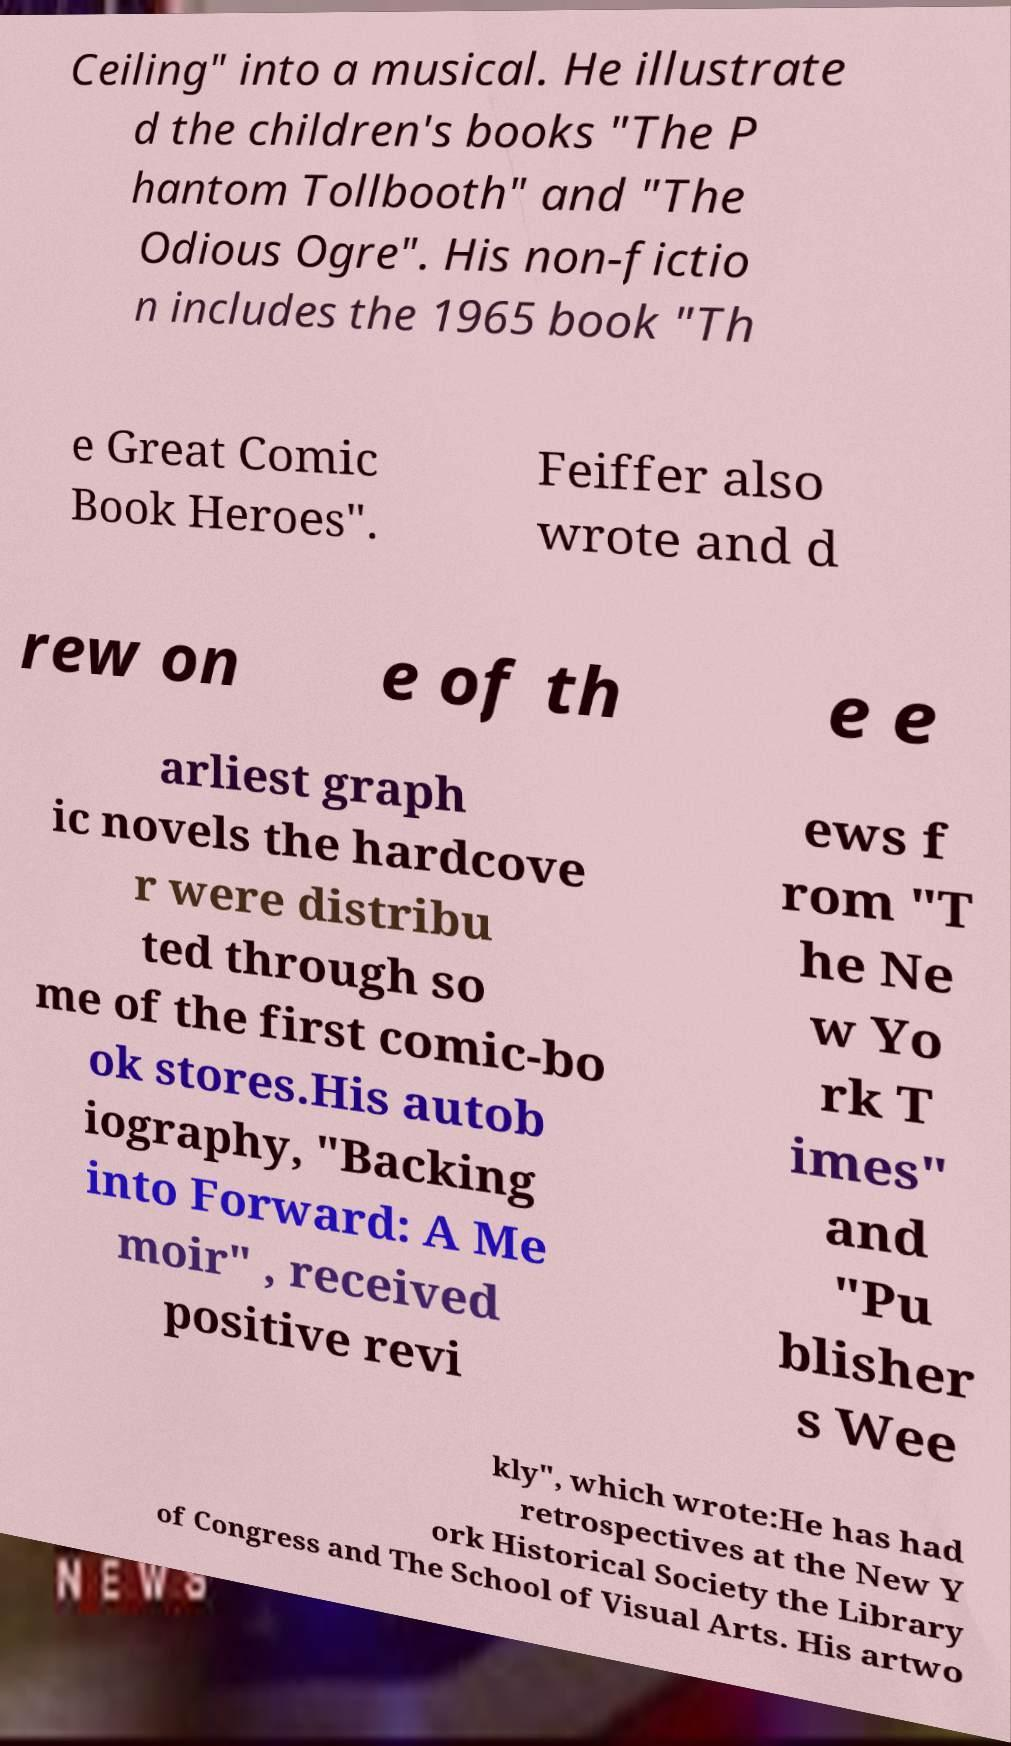What messages or text are displayed in this image? I need them in a readable, typed format. Ceiling" into a musical. He illustrate d the children's books "The P hantom Tollbooth" and "The Odious Ogre". His non-fictio n includes the 1965 book "Th e Great Comic Book Heroes". Feiffer also wrote and d rew on e of th e e arliest graph ic novels the hardcove r were distribu ted through so me of the first comic-bo ok stores.His autob iography, "Backing into Forward: A Me moir" , received positive revi ews f rom "T he Ne w Yo rk T imes" and "Pu blisher s Wee kly", which wrote:He has had retrospectives at the New Y ork Historical Society the Library of Congress and The School of Visual Arts. His artwo 